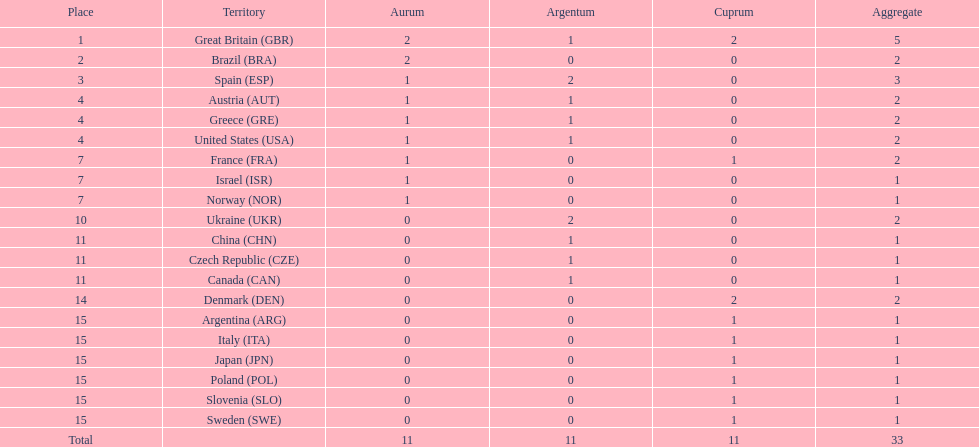How many countries won at least 1 gold and 1 silver medal? 5. 